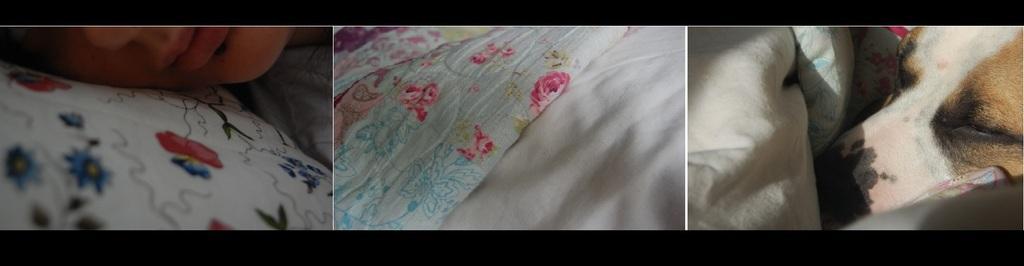Please provide a concise description of this image. This image is a collage. In the first image we can see a person sleeping on the pillow. In the second image there is a blanket and a cloth. In the third image there is a dog and clothes. 